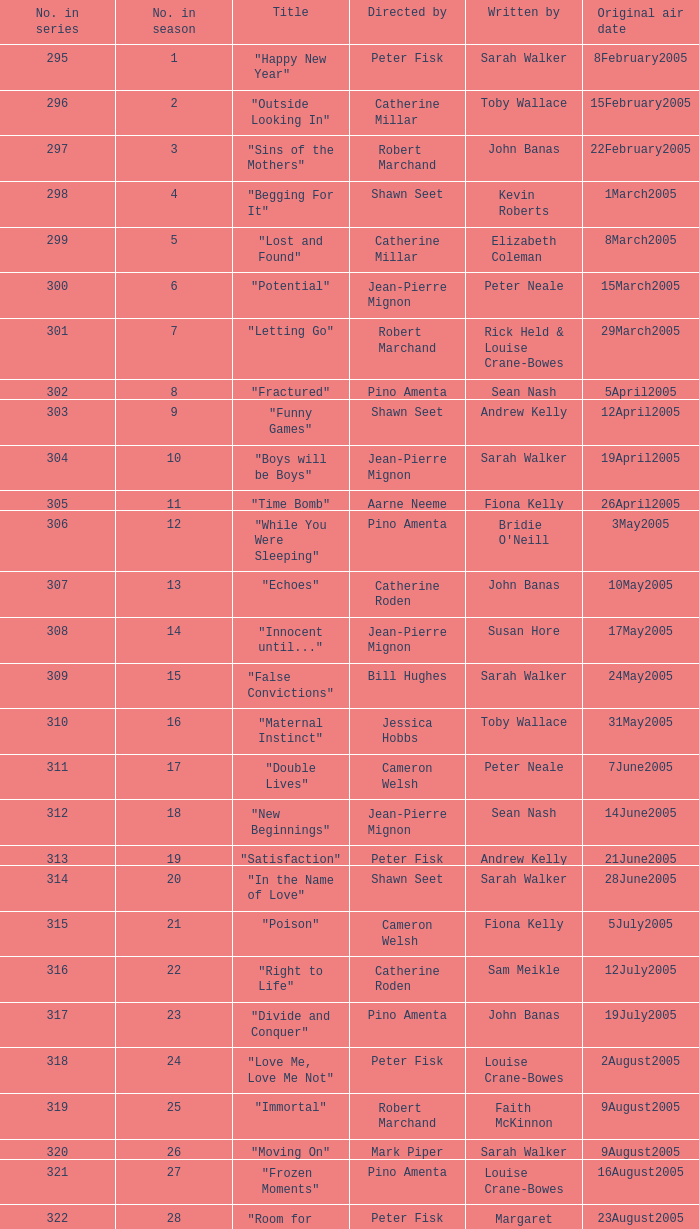Name the total number in the series written by john banas and directed by pino amenta 1.0. 